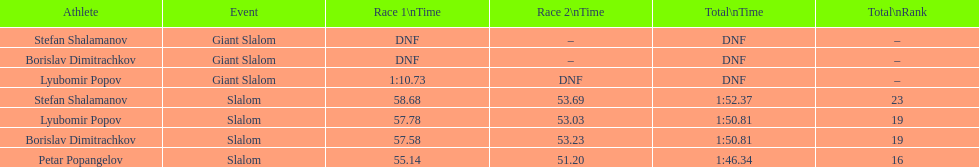I'm looking to parse the entire table for insights. Could you assist me with that? {'header': ['Athlete', 'Event', 'Race 1\\nTime', 'Race 2\\nTime', 'Total\\nTime', 'Total\\nRank'], 'rows': [['Stefan Shalamanov', 'Giant Slalom', 'DNF', '–', 'DNF', '–'], ['Borislav Dimitrachkov', 'Giant Slalom', 'DNF', '–', 'DNF', '–'], ['Lyubomir Popov', 'Giant Slalom', '1:10.73', 'DNF', 'DNF', '–'], ['Stefan Shalamanov', 'Slalom', '58.68', '53.69', '1:52.37', '23'], ['Lyubomir Popov', 'Slalom', '57.78', '53.03', '1:50.81', '19'], ['Borislav Dimitrachkov', 'Slalom', '57.58', '53.23', '1:50.81', '19'], ['Petar Popangelov', 'Slalom', '55.14', '51.20', '1:46.34', '16']]} Who possesses the greatest ranking? Petar Popangelov. 